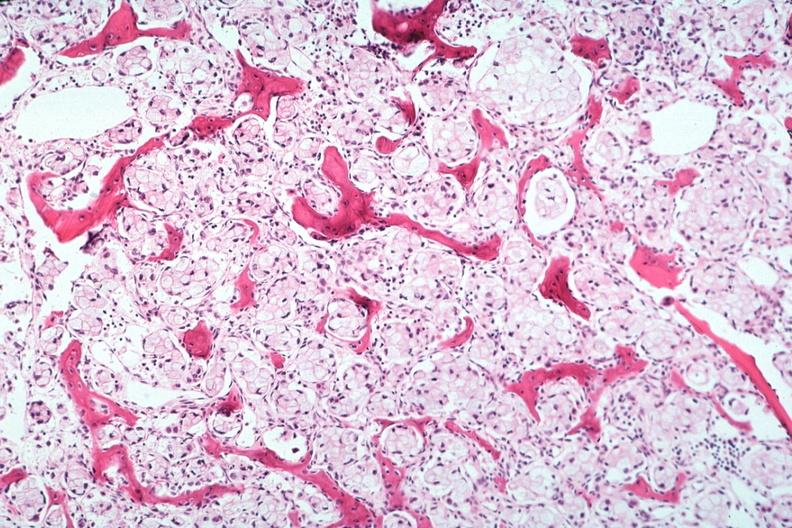what does this image show?
Answer the question using a single word or phrase. Stomach primary 